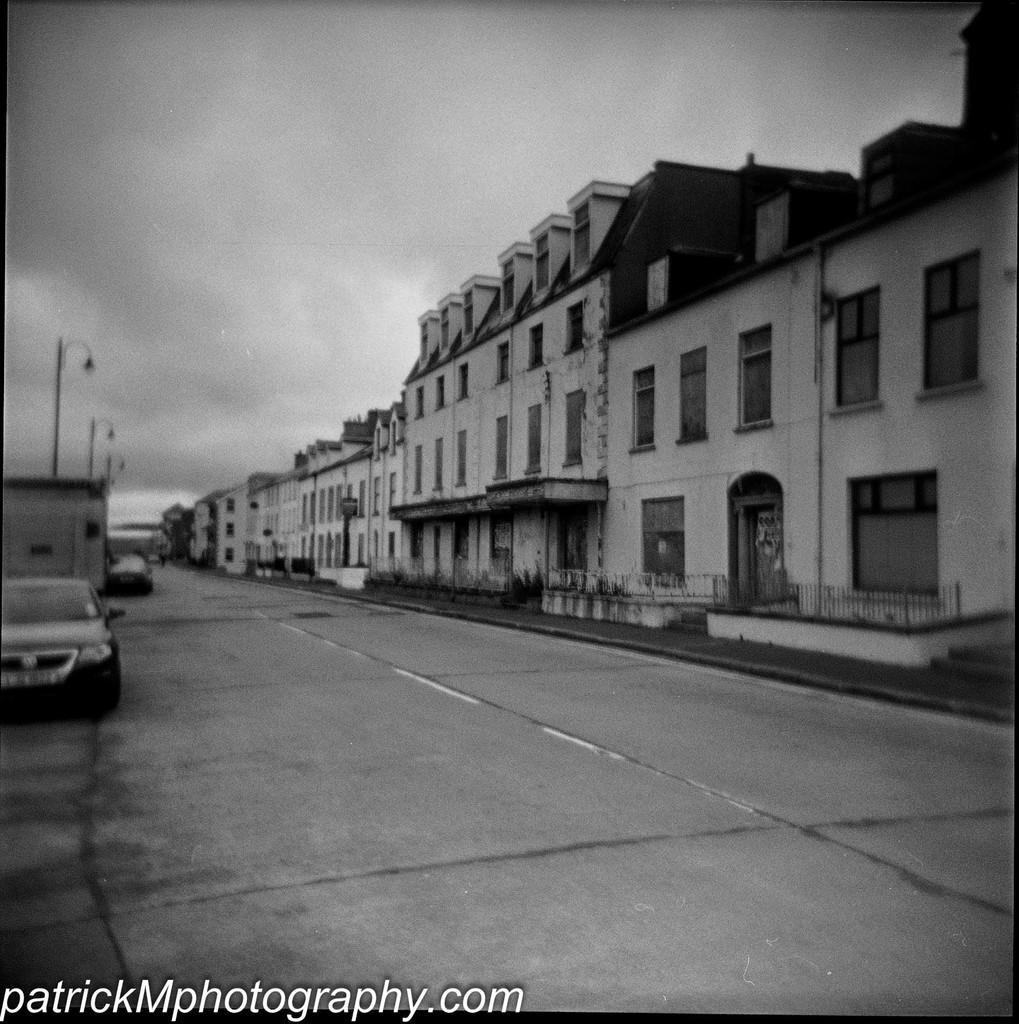Describe this image in one or two sentences. This is a black and white image. On the right side there are some buildings, in front of the building there is a road. On the road there are some vehicles. In the background there is a sky. 